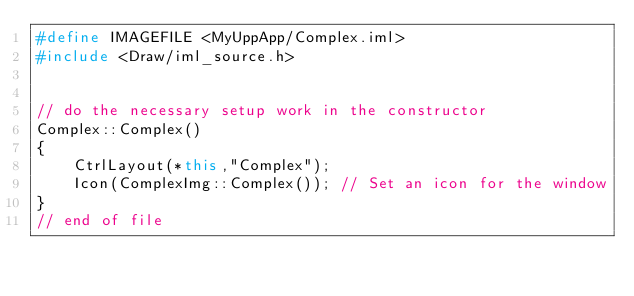<code> <loc_0><loc_0><loc_500><loc_500><_C++_>#define IMAGEFILE <MyUppApp/Complex.iml>
#include <Draw/iml_source.h>


// do the necessary setup work in the constructor
Complex::Complex()
{
	CtrlLayout(*this,"Complex");
	Icon(ComplexImg::Complex()); // Set an icon for the window
}
// end of file
</code> 